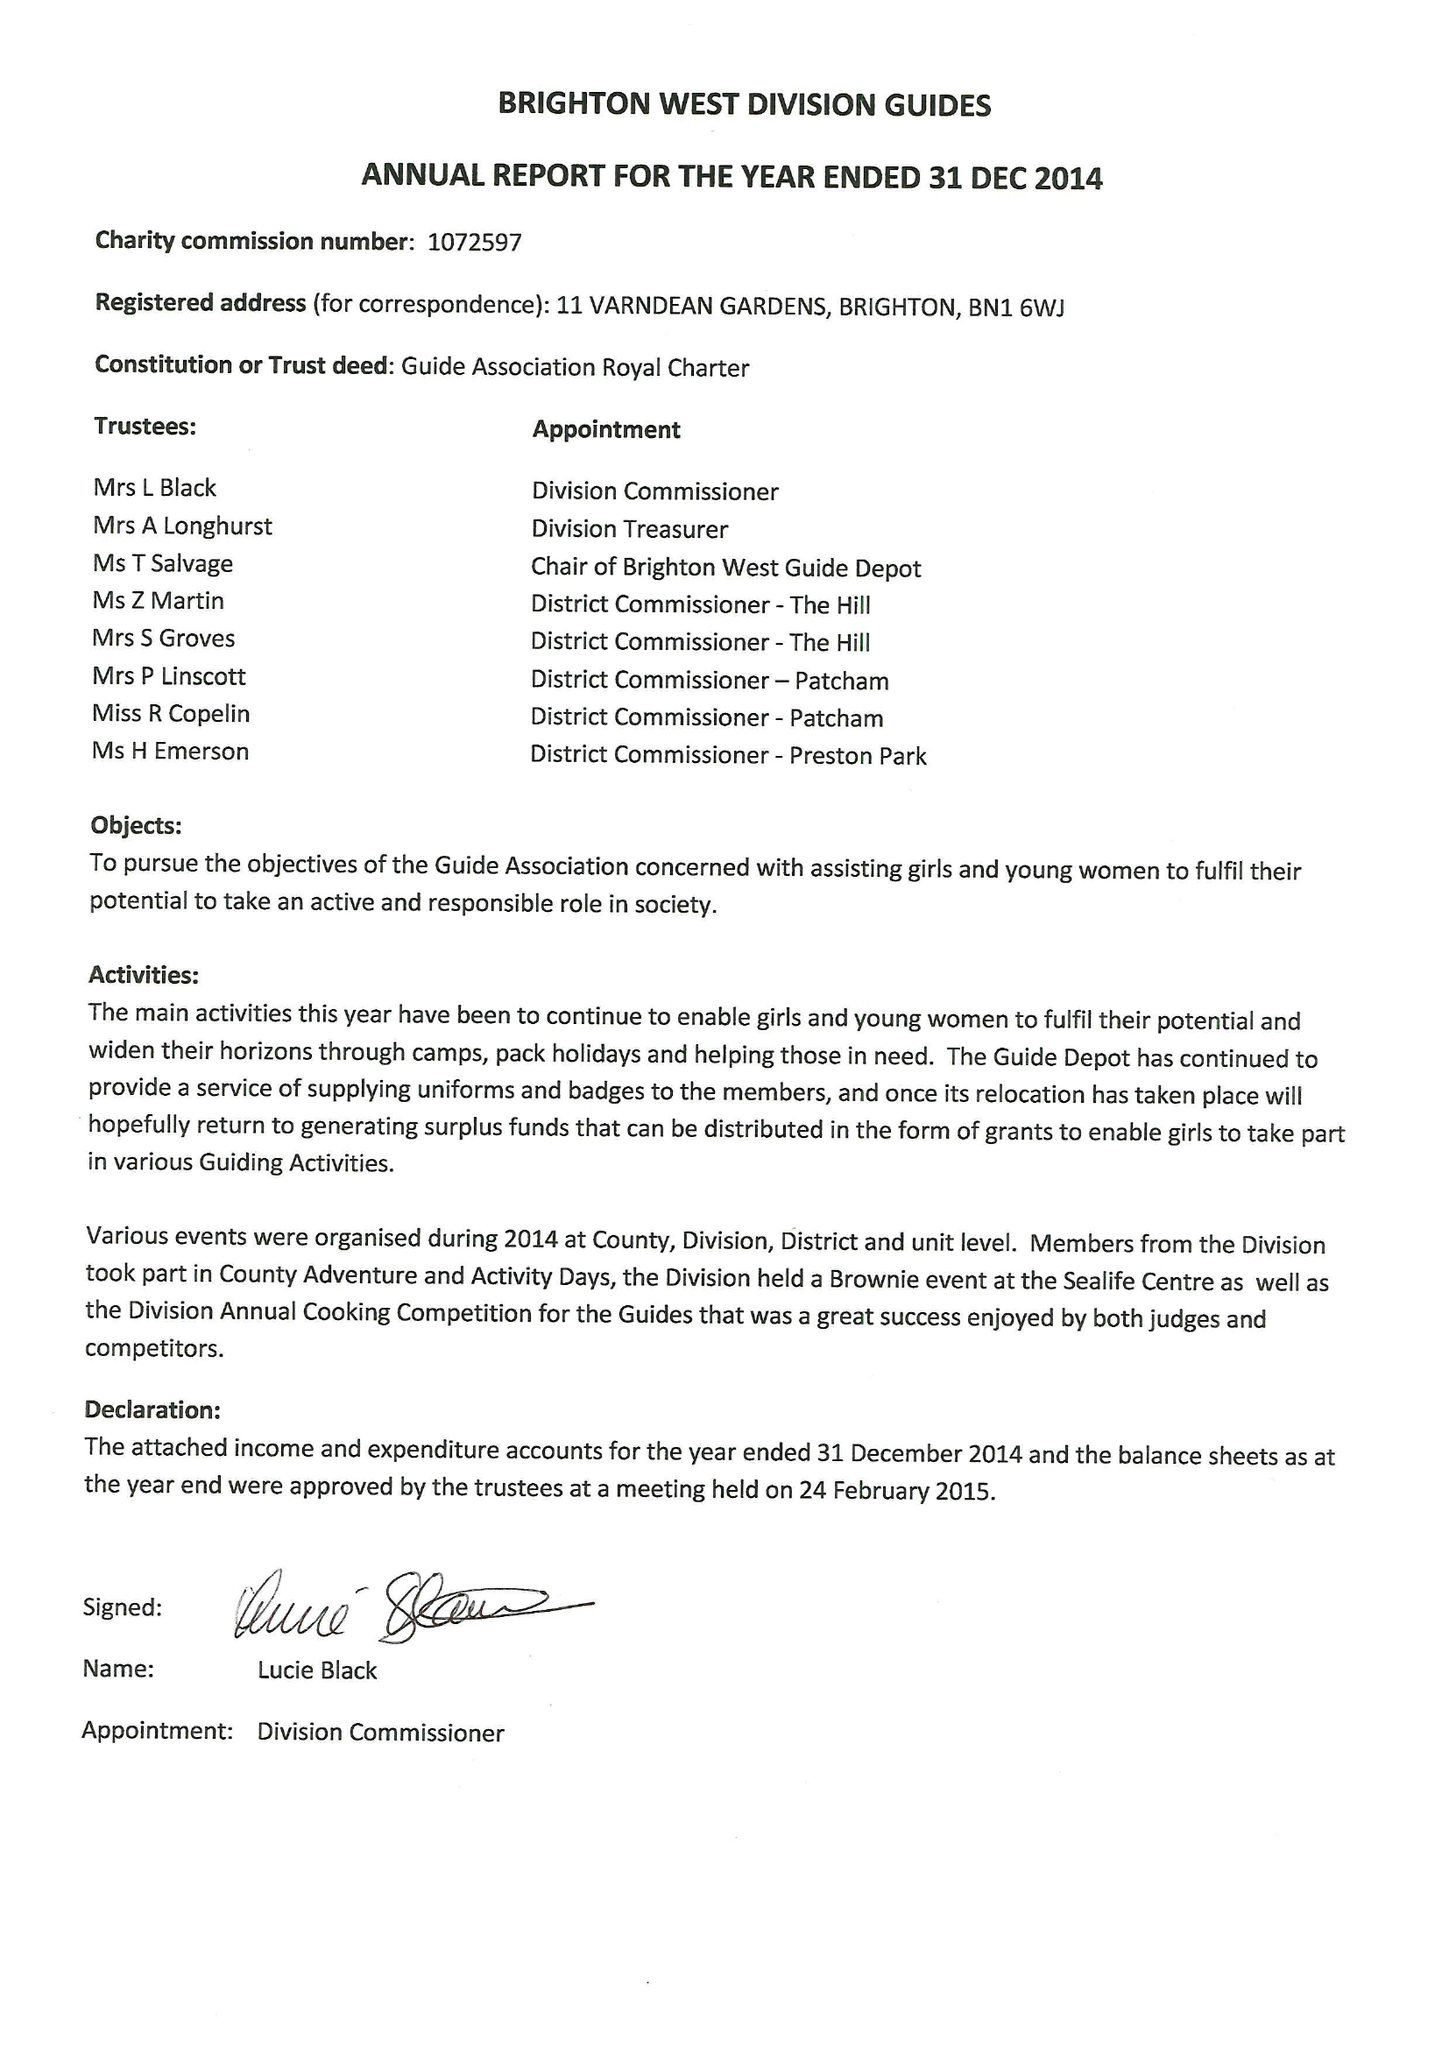What is the value for the report_date?
Answer the question using a single word or phrase. 2014-12-31 